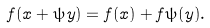<formula> <loc_0><loc_0><loc_500><loc_500>f ( x + \psi y ) = f ( x ) + f \psi ( y ) .</formula> 